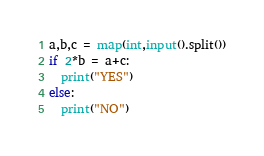<code> <loc_0><loc_0><loc_500><loc_500><_Python_>a,b,c = map(int,input().split())
if 2*b = a+c:
  print("YES")
else:
  print("NO")</code> 